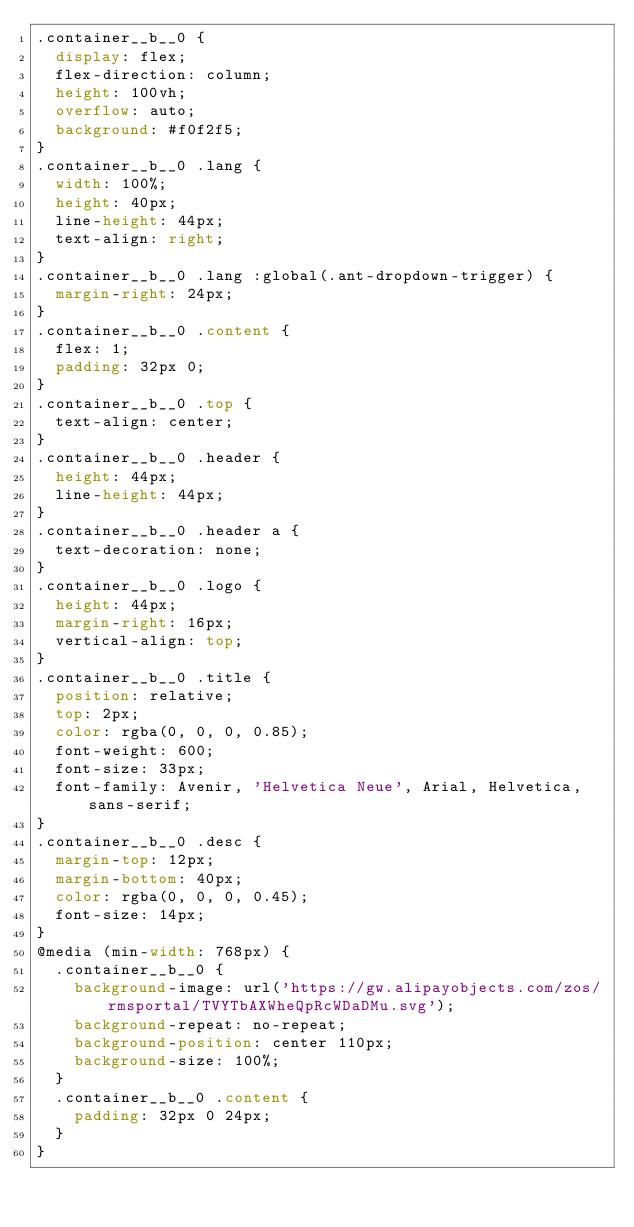Convert code to text. <code><loc_0><loc_0><loc_500><loc_500><_CSS_>.container__b__0 {
  display: flex;
  flex-direction: column;
  height: 100vh;
  overflow: auto;
  background: #f0f2f5;
}
.container__b__0 .lang {
  width: 100%;
  height: 40px;
  line-height: 44px;
  text-align: right;
}
.container__b__0 .lang :global(.ant-dropdown-trigger) {
  margin-right: 24px;
}
.container__b__0 .content {
  flex: 1;
  padding: 32px 0;
}
.container__b__0 .top {
  text-align: center;
}
.container__b__0 .header {
  height: 44px;
  line-height: 44px;
}
.container__b__0 .header a {
  text-decoration: none;
}
.container__b__0 .logo {
  height: 44px;
  margin-right: 16px;
  vertical-align: top;
}
.container__b__0 .title {
  position: relative;
  top: 2px;
  color: rgba(0, 0, 0, 0.85);
  font-weight: 600;
  font-size: 33px;
  font-family: Avenir, 'Helvetica Neue', Arial, Helvetica, sans-serif;
}
.container__b__0 .desc {
  margin-top: 12px;
  margin-bottom: 40px;
  color: rgba(0, 0, 0, 0.45);
  font-size: 14px;
}
@media (min-width: 768px) {
  .container__b__0 {
    background-image: url('https://gw.alipayobjects.com/zos/rmsportal/TVYTbAXWheQpRcWDaDMu.svg');
    background-repeat: no-repeat;
    background-position: center 110px;
    background-size: 100%;
  }
  .container__b__0 .content {
    padding: 32px 0 24px;
  }
}
</code> 